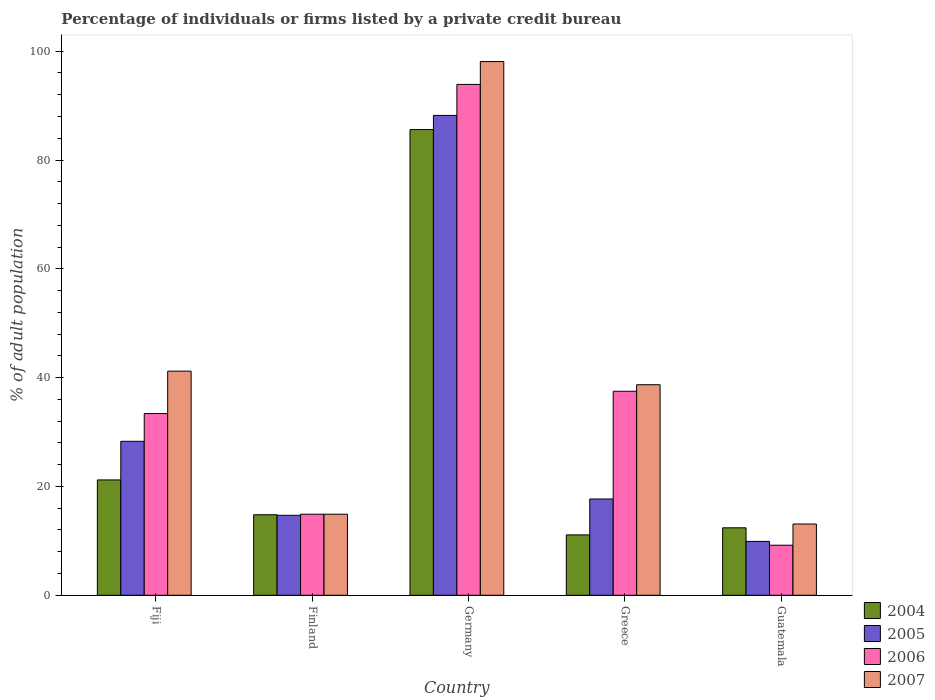How many different coloured bars are there?
Your response must be concise. 4. How many groups of bars are there?
Your answer should be compact. 5. Are the number of bars per tick equal to the number of legend labels?
Your response must be concise. Yes. Are the number of bars on each tick of the X-axis equal?
Offer a terse response. Yes. In how many cases, is the number of bars for a given country not equal to the number of legend labels?
Ensure brevity in your answer.  0. What is the percentage of population listed by a private credit bureau in 2004 in Germany?
Offer a very short reply. 85.6. Across all countries, what is the maximum percentage of population listed by a private credit bureau in 2004?
Your answer should be very brief. 85.6. Across all countries, what is the minimum percentage of population listed by a private credit bureau in 2004?
Provide a short and direct response. 11.1. In which country was the percentage of population listed by a private credit bureau in 2004 maximum?
Your answer should be very brief. Germany. What is the total percentage of population listed by a private credit bureau in 2006 in the graph?
Your response must be concise. 188.9. What is the difference between the percentage of population listed by a private credit bureau in 2007 in Fiji and that in Germany?
Provide a succinct answer. -56.9. What is the difference between the percentage of population listed by a private credit bureau in 2005 in Fiji and the percentage of population listed by a private credit bureau in 2004 in Finland?
Provide a succinct answer. 13.5. What is the average percentage of population listed by a private credit bureau in 2007 per country?
Ensure brevity in your answer.  41.2. What is the difference between the percentage of population listed by a private credit bureau of/in 2007 and percentage of population listed by a private credit bureau of/in 2005 in Greece?
Keep it short and to the point. 21. In how many countries, is the percentage of population listed by a private credit bureau in 2004 greater than 68 %?
Ensure brevity in your answer.  1. What is the ratio of the percentage of population listed by a private credit bureau in 2007 in Finland to that in Guatemala?
Keep it short and to the point. 1.14. Is the percentage of population listed by a private credit bureau in 2007 in Finland less than that in Guatemala?
Make the answer very short. No. What is the difference between the highest and the second highest percentage of population listed by a private credit bureau in 2004?
Provide a succinct answer. -64.4. What does the 2nd bar from the left in Fiji represents?
Your answer should be very brief. 2005. How many bars are there?
Ensure brevity in your answer.  20. Are all the bars in the graph horizontal?
Offer a very short reply. No. How many countries are there in the graph?
Offer a very short reply. 5. Are the values on the major ticks of Y-axis written in scientific E-notation?
Your response must be concise. No. Does the graph contain grids?
Make the answer very short. No. Where does the legend appear in the graph?
Make the answer very short. Bottom right. What is the title of the graph?
Keep it short and to the point. Percentage of individuals or firms listed by a private credit bureau. What is the label or title of the X-axis?
Give a very brief answer. Country. What is the label or title of the Y-axis?
Offer a terse response. % of adult population. What is the % of adult population in 2004 in Fiji?
Offer a terse response. 21.2. What is the % of adult population in 2005 in Fiji?
Your answer should be compact. 28.3. What is the % of adult population of 2006 in Fiji?
Your answer should be very brief. 33.4. What is the % of adult population of 2007 in Fiji?
Give a very brief answer. 41.2. What is the % of adult population in 2004 in Finland?
Your answer should be very brief. 14.8. What is the % of adult population of 2006 in Finland?
Your answer should be compact. 14.9. What is the % of adult population of 2004 in Germany?
Provide a short and direct response. 85.6. What is the % of adult population of 2005 in Germany?
Your answer should be compact. 88.2. What is the % of adult population of 2006 in Germany?
Give a very brief answer. 93.9. What is the % of adult population in 2007 in Germany?
Give a very brief answer. 98.1. What is the % of adult population in 2006 in Greece?
Keep it short and to the point. 37.5. What is the % of adult population in 2007 in Greece?
Provide a short and direct response. 38.7. What is the % of adult population of 2005 in Guatemala?
Make the answer very short. 9.9. What is the % of adult population of 2006 in Guatemala?
Offer a terse response. 9.2. Across all countries, what is the maximum % of adult population of 2004?
Make the answer very short. 85.6. Across all countries, what is the maximum % of adult population of 2005?
Your answer should be very brief. 88.2. Across all countries, what is the maximum % of adult population of 2006?
Offer a very short reply. 93.9. Across all countries, what is the maximum % of adult population of 2007?
Make the answer very short. 98.1. Across all countries, what is the minimum % of adult population of 2004?
Your response must be concise. 11.1. Across all countries, what is the minimum % of adult population in 2005?
Make the answer very short. 9.9. Across all countries, what is the minimum % of adult population of 2006?
Your response must be concise. 9.2. What is the total % of adult population of 2004 in the graph?
Keep it short and to the point. 145.1. What is the total % of adult population in 2005 in the graph?
Make the answer very short. 158.8. What is the total % of adult population in 2006 in the graph?
Provide a short and direct response. 188.9. What is the total % of adult population of 2007 in the graph?
Offer a terse response. 206. What is the difference between the % of adult population in 2004 in Fiji and that in Finland?
Provide a succinct answer. 6.4. What is the difference between the % of adult population in 2005 in Fiji and that in Finland?
Provide a succinct answer. 13.6. What is the difference between the % of adult population in 2007 in Fiji and that in Finland?
Provide a short and direct response. 26.3. What is the difference between the % of adult population of 2004 in Fiji and that in Germany?
Your response must be concise. -64.4. What is the difference between the % of adult population in 2005 in Fiji and that in Germany?
Give a very brief answer. -59.9. What is the difference between the % of adult population of 2006 in Fiji and that in Germany?
Your response must be concise. -60.5. What is the difference between the % of adult population of 2007 in Fiji and that in Germany?
Your response must be concise. -56.9. What is the difference between the % of adult population of 2004 in Fiji and that in Greece?
Provide a short and direct response. 10.1. What is the difference between the % of adult population in 2005 in Fiji and that in Greece?
Provide a succinct answer. 10.6. What is the difference between the % of adult population in 2007 in Fiji and that in Greece?
Provide a succinct answer. 2.5. What is the difference between the % of adult population of 2004 in Fiji and that in Guatemala?
Provide a short and direct response. 8.8. What is the difference between the % of adult population of 2006 in Fiji and that in Guatemala?
Keep it short and to the point. 24.2. What is the difference between the % of adult population of 2007 in Fiji and that in Guatemala?
Offer a very short reply. 28.1. What is the difference between the % of adult population of 2004 in Finland and that in Germany?
Give a very brief answer. -70.8. What is the difference between the % of adult population of 2005 in Finland and that in Germany?
Your response must be concise. -73.5. What is the difference between the % of adult population of 2006 in Finland and that in Germany?
Your response must be concise. -79. What is the difference between the % of adult population in 2007 in Finland and that in Germany?
Your answer should be compact. -83.2. What is the difference between the % of adult population of 2004 in Finland and that in Greece?
Your response must be concise. 3.7. What is the difference between the % of adult population of 2005 in Finland and that in Greece?
Your answer should be compact. -3. What is the difference between the % of adult population of 2006 in Finland and that in Greece?
Give a very brief answer. -22.6. What is the difference between the % of adult population in 2007 in Finland and that in Greece?
Make the answer very short. -23.8. What is the difference between the % of adult population of 2004 in Finland and that in Guatemala?
Your response must be concise. 2.4. What is the difference between the % of adult population in 2006 in Finland and that in Guatemala?
Your answer should be very brief. 5.7. What is the difference between the % of adult population of 2004 in Germany and that in Greece?
Ensure brevity in your answer.  74.5. What is the difference between the % of adult population of 2005 in Germany and that in Greece?
Give a very brief answer. 70.5. What is the difference between the % of adult population in 2006 in Germany and that in Greece?
Ensure brevity in your answer.  56.4. What is the difference between the % of adult population of 2007 in Germany and that in Greece?
Offer a very short reply. 59.4. What is the difference between the % of adult population in 2004 in Germany and that in Guatemala?
Offer a very short reply. 73.2. What is the difference between the % of adult population in 2005 in Germany and that in Guatemala?
Your response must be concise. 78.3. What is the difference between the % of adult population of 2006 in Germany and that in Guatemala?
Make the answer very short. 84.7. What is the difference between the % of adult population in 2005 in Greece and that in Guatemala?
Offer a very short reply. 7.8. What is the difference between the % of adult population in 2006 in Greece and that in Guatemala?
Provide a succinct answer. 28.3. What is the difference between the % of adult population in 2007 in Greece and that in Guatemala?
Make the answer very short. 25.6. What is the difference between the % of adult population of 2004 in Fiji and the % of adult population of 2006 in Finland?
Offer a very short reply. 6.3. What is the difference between the % of adult population in 2004 in Fiji and the % of adult population in 2007 in Finland?
Keep it short and to the point. 6.3. What is the difference between the % of adult population of 2005 in Fiji and the % of adult population of 2006 in Finland?
Provide a succinct answer. 13.4. What is the difference between the % of adult population in 2005 in Fiji and the % of adult population in 2007 in Finland?
Provide a short and direct response. 13.4. What is the difference between the % of adult population in 2004 in Fiji and the % of adult population in 2005 in Germany?
Your answer should be compact. -67. What is the difference between the % of adult population in 2004 in Fiji and the % of adult population in 2006 in Germany?
Keep it short and to the point. -72.7. What is the difference between the % of adult population of 2004 in Fiji and the % of adult population of 2007 in Germany?
Your answer should be compact. -76.9. What is the difference between the % of adult population of 2005 in Fiji and the % of adult population of 2006 in Germany?
Ensure brevity in your answer.  -65.6. What is the difference between the % of adult population of 2005 in Fiji and the % of adult population of 2007 in Germany?
Your answer should be very brief. -69.8. What is the difference between the % of adult population of 2006 in Fiji and the % of adult population of 2007 in Germany?
Give a very brief answer. -64.7. What is the difference between the % of adult population of 2004 in Fiji and the % of adult population of 2005 in Greece?
Provide a short and direct response. 3.5. What is the difference between the % of adult population of 2004 in Fiji and the % of adult population of 2006 in Greece?
Make the answer very short. -16.3. What is the difference between the % of adult population in 2004 in Fiji and the % of adult population in 2007 in Greece?
Provide a succinct answer. -17.5. What is the difference between the % of adult population in 2005 in Fiji and the % of adult population in 2006 in Greece?
Give a very brief answer. -9.2. What is the difference between the % of adult population of 2005 in Fiji and the % of adult population of 2007 in Greece?
Ensure brevity in your answer.  -10.4. What is the difference between the % of adult population of 2004 in Fiji and the % of adult population of 2005 in Guatemala?
Give a very brief answer. 11.3. What is the difference between the % of adult population of 2005 in Fiji and the % of adult population of 2006 in Guatemala?
Provide a short and direct response. 19.1. What is the difference between the % of adult population of 2006 in Fiji and the % of adult population of 2007 in Guatemala?
Your answer should be compact. 20.3. What is the difference between the % of adult population of 2004 in Finland and the % of adult population of 2005 in Germany?
Your answer should be very brief. -73.4. What is the difference between the % of adult population in 2004 in Finland and the % of adult population in 2006 in Germany?
Give a very brief answer. -79.1. What is the difference between the % of adult population in 2004 in Finland and the % of adult population in 2007 in Germany?
Your response must be concise. -83.3. What is the difference between the % of adult population in 2005 in Finland and the % of adult population in 2006 in Germany?
Make the answer very short. -79.2. What is the difference between the % of adult population of 2005 in Finland and the % of adult population of 2007 in Germany?
Provide a short and direct response. -83.4. What is the difference between the % of adult population of 2006 in Finland and the % of adult population of 2007 in Germany?
Your answer should be compact. -83.2. What is the difference between the % of adult population in 2004 in Finland and the % of adult population in 2005 in Greece?
Your answer should be compact. -2.9. What is the difference between the % of adult population of 2004 in Finland and the % of adult population of 2006 in Greece?
Offer a terse response. -22.7. What is the difference between the % of adult population of 2004 in Finland and the % of adult population of 2007 in Greece?
Ensure brevity in your answer.  -23.9. What is the difference between the % of adult population of 2005 in Finland and the % of adult population of 2006 in Greece?
Ensure brevity in your answer.  -22.8. What is the difference between the % of adult population of 2005 in Finland and the % of adult population of 2007 in Greece?
Provide a succinct answer. -24. What is the difference between the % of adult population of 2006 in Finland and the % of adult population of 2007 in Greece?
Give a very brief answer. -23.8. What is the difference between the % of adult population of 2004 in Finland and the % of adult population of 2006 in Guatemala?
Provide a short and direct response. 5.6. What is the difference between the % of adult population of 2005 in Finland and the % of adult population of 2007 in Guatemala?
Provide a succinct answer. 1.6. What is the difference between the % of adult population in 2006 in Finland and the % of adult population in 2007 in Guatemala?
Provide a short and direct response. 1.8. What is the difference between the % of adult population of 2004 in Germany and the % of adult population of 2005 in Greece?
Offer a very short reply. 67.9. What is the difference between the % of adult population of 2004 in Germany and the % of adult population of 2006 in Greece?
Offer a very short reply. 48.1. What is the difference between the % of adult population of 2004 in Germany and the % of adult population of 2007 in Greece?
Offer a terse response. 46.9. What is the difference between the % of adult population in 2005 in Germany and the % of adult population in 2006 in Greece?
Provide a short and direct response. 50.7. What is the difference between the % of adult population of 2005 in Germany and the % of adult population of 2007 in Greece?
Your answer should be very brief. 49.5. What is the difference between the % of adult population in 2006 in Germany and the % of adult population in 2007 in Greece?
Provide a short and direct response. 55.2. What is the difference between the % of adult population in 2004 in Germany and the % of adult population in 2005 in Guatemala?
Provide a short and direct response. 75.7. What is the difference between the % of adult population in 2004 in Germany and the % of adult population in 2006 in Guatemala?
Your answer should be compact. 76.4. What is the difference between the % of adult population in 2004 in Germany and the % of adult population in 2007 in Guatemala?
Your response must be concise. 72.5. What is the difference between the % of adult population in 2005 in Germany and the % of adult population in 2006 in Guatemala?
Your answer should be very brief. 79. What is the difference between the % of adult population in 2005 in Germany and the % of adult population in 2007 in Guatemala?
Make the answer very short. 75.1. What is the difference between the % of adult population in 2006 in Germany and the % of adult population in 2007 in Guatemala?
Provide a short and direct response. 80.8. What is the difference between the % of adult population of 2004 in Greece and the % of adult population of 2005 in Guatemala?
Keep it short and to the point. 1.2. What is the difference between the % of adult population in 2004 in Greece and the % of adult population in 2006 in Guatemala?
Your response must be concise. 1.9. What is the difference between the % of adult population of 2005 in Greece and the % of adult population of 2006 in Guatemala?
Offer a terse response. 8.5. What is the difference between the % of adult population in 2005 in Greece and the % of adult population in 2007 in Guatemala?
Offer a terse response. 4.6. What is the difference between the % of adult population of 2006 in Greece and the % of adult population of 2007 in Guatemala?
Provide a short and direct response. 24.4. What is the average % of adult population in 2004 per country?
Your answer should be compact. 29.02. What is the average % of adult population of 2005 per country?
Ensure brevity in your answer.  31.76. What is the average % of adult population of 2006 per country?
Your answer should be compact. 37.78. What is the average % of adult population of 2007 per country?
Offer a terse response. 41.2. What is the difference between the % of adult population of 2004 and % of adult population of 2006 in Fiji?
Give a very brief answer. -12.2. What is the difference between the % of adult population of 2004 and % of adult population of 2005 in Finland?
Your answer should be compact. 0.1. What is the difference between the % of adult population of 2004 and % of adult population of 2007 in Finland?
Provide a short and direct response. -0.1. What is the difference between the % of adult population of 2005 and % of adult population of 2006 in Finland?
Provide a succinct answer. -0.2. What is the difference between the % of adult population in 2006 and % of adult population in 2007 in Finland?
Provide a short and direct response. 0. What is the difference between the % of adult population in 2004 and % of adult population in 2005 in Germany?
Provide a short and direct response. -2.6. What is the difference between the % of adult population in 2004 and % of adult population in 2007 in Germany?
Offer a terse response. -12.5. What is the difference between the % of adult population of 2004 and % of adult population of 2005 in Greece?
Offer a terse response. -6.6. What is the difference between the % of adult population of 2004 and % of adult population of 2006 in Greece?
Offer a very short reply. -26.4. What is the difference between the % of adult population in 2004 and % of adult population in 2007 in Greece?
Your answer should be very brief. -27.6. What is the difference between the % of adult population of 2005 and % of adult population of 2006 in Greece?
Your answer should be compact. -19.8. What is the difference between the % of adult population of 2005 and % of adult population of 2007 in Greece?
Make the answer very short. -21. What is the difference between the % of adult population of 2006 and % of adult population of 2007 in Greece?
Your response must be concise. -1.2. What is the difference between the % of adult population of 2004 and % of adult population of 2005 in Guatemala?
Your answer should be very brief. 2.5. What is the difference between the % of adult population in 2004 and % of adult population in 2007 in Guatemala?
Provide a short and direct response. -0.7. What is the difference between the % of adult population in 2005 and % of adult population in 2006 in Guatemala?
Provide a short and direct response. 0.7. What is the difference between the % of adult population in 2005 and % of adult population in 2007 in Guatemala?
Offer a very short reply. -3.2. What is the difference between the % of adult population of 2006 and % of adult population of 2007 in Guatemala?
Offer a very short reply. -3.9. What is the ratio of the % of adult population of 2004 in Fiji to that in Finland?
Provide a succinct answer. 1.43. What is the ratio of the % of adult population in 2005 in Fiji to that in Finland?
Make the answer very short. 1.93. What is the ratio of the % of adult population of 2006 in Fiji to that in Finland?
Keep it short and to the point. 2.24. What is the ratio of the % of adult population of 2007 in Fiji to that in Finland?
Provide a succinct answer. 2.77. What is the ratio of the % of adult population in 2004 in Fiji to that in Germany?
Offer a very short reply. 0.25. What is the ratio of the % of adult population in 2005 in Fiji to that in Germany?
Make the answer very short. 0.32. What is the ratio of the % of adult population of 2006 in Fiji to that in Germany?
Provide a succinct answer. 0.36. What is the ratio of the % of adult population in 2007 in Fiji to that in Germany?
Provide a short and direct response. 0.42. What is the ratio of the % of adult population in 2004 in Fiji to that in Greece?
Your response must be concise. 1.91. What is the ratio of the % of adult population in 2005 in Fiji to that in Greece?
Ensure brevity in your answer.  1.6. What is the ratio of the % of adult population of 2006 in Fiji to that in Greece?
Offer a terse response. 0.89. What is the ratio of the % of adult population of 2007 in Fiji to that in Greece?
Offer a very short reply. 1.06. What is the ratio of the % of adult population in 2004 in Fiji to that in Guatemala?
Provide a short and direct response. 1.71. What is the ratio of the % of adult population of 2005 in Fiji to that in Guatemala?
Provide a succinct answer. 2.86. What is the ratio of the % of adult population of 2006 in Fiji to that in Guatemala?
Keep it short and to the point. 3.63. What is the ratio of the % of adult population in 2007 in Fiji to that in Guatemala?
Keep it short and to the point. 3.15. What is the ratio of the % of adult population of 2004 in Finland to that in Germany?
Ensure brevity in your answer.  0.17. What is the ratio of the % of adult population of 2005 in Finland to that in Germany?
Your answer should be very brief. 0.17. What is the ratio of the % of adult population in 2006 in Finland to that in Germany?
Give a very brief answer. 0.16. What is the ratio of the % of adult population of 2007 in Finland to that in Germany?
Your response must be concise. 0.15. What is the ratio of the % of adult population in 2005 in Finland to that in Greece?
Provide a succinct answer. 0.83. What is the ratio of the % of adult population of 2006 in Finland to that in Greece?
Give a very brief answer. 0.4. What is the ratio of the % of adult population of 2007 in Finland to that in Greece?
Provide a succinct answer. 0.39. What is the ratio of the % of adult population of 2004 in Finland to that in Guatemala?
Offer a very short reply. 1.19. What is the ratio of the % of adult population in 2005 in Finland to that in Guatemala?
Your answer should be compact. 1.48. What is the ratio of the % of adult population of 2006 in Finland to that in Guatemala?
Your answer should be very brief. 1.62. What is the ratio of the % of adult population in 2007 in Finland to that in Guatemala?
Your answer should be compact. 1.14. What is the ratio of the % of adult population of 2004 in Germany to that in Greece?
Your answer should be very brief. 7.71. What is the ratio of the % of adult population of 2005 in Germany to that in Greece?
Offer a very short reply. 4.98. What is the ratio of the % of adult population of 2006 in Germany to that in Greece?
Provide a short and direct response. 2.5. What is the ratio of the % of adult population in 2007 in Germany to that in Greece?
Offer a terse response. 2.53. What is the ratio of the % of adult population of 2004 in Germany to that in Guatemala?
Make the answer very short. 6.9. What is the ratio of the % of adult population in 2005 in Germany to that in Guatemala?
Your answer should be compact. 8.91. What is the ratio of the % of adult population in 2006 in Germany to that in Guatemala?
Make the answer very short. 10.21. What is the ratio of the % of adult population of 2007 in Germany to that in Guatemala?
Keep it short and to the point. 7.49. What is the ratio of the % of adult population of 2004 in Greece to that in Guatemala?
Provide a short and direct response. 0.9. What is the ratio of the % of adult population in 2005 in Greece to that in Guatemala?
Your answer should be very brief. 1.79. What is the ratio of the % of adult population in 2006 in Greece to that in Guatemala?
Your response must be concise. 4.08. What is the ratio of the % of adult population in 2007 in Greece to that in Guatemala?
Ensure brevity in your answer.  2.95. What is the difference between the highest and the second highest % of adult population in 2004?
Ensure brevity in your answer.  64.4. What is the difference between the highest and the second highest % of adult population of 2005?
Make the answer very short. 59.9. What is the difference between the highest and the second highest % of adult population of 2006?
Offer a very short reply. 56.4. What is the difference between the highest and the second highest % of adult population of 2007?
Give a very brief answer. 56.9. What is the difference between the highest and the lowest % of adult population in 2004?
Ensure brevity in your answer.  74.5. What is the difference between the highest and the lowest % of adult population of 2005?
Make the answer very short. 78.3. What is the difference between the highest and the lowest % of adult population of 2006?
Offer a very short reply. 84.7. What is the difference between the highest and the lowest % of adult population in 2007?
Make the answer very short. 85. 